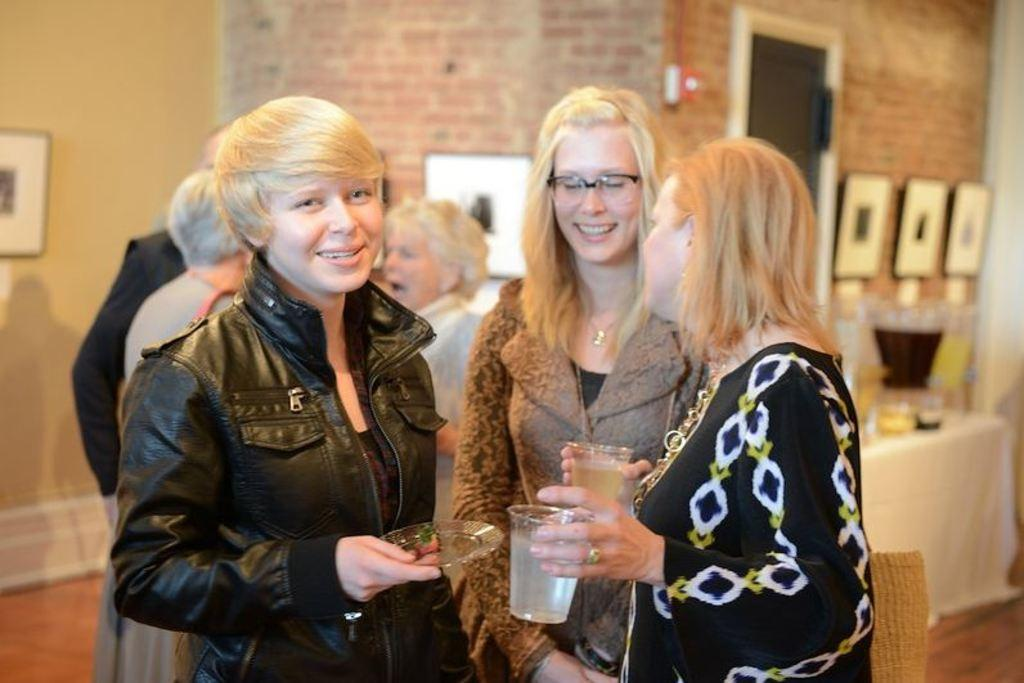What is the main subject of the image? There are two girls standing in the image. Can you describe the appearance of the first girl? The first girl is beautiful and is wearing a black coat. How about the second girl? The second girl is wearing spectacles. What can be seen in the background of the image? There is a brick wall in the background of the image. How many fingers does the fan have in the image? There is no fan present in the image. What type of stretch can be seen in the image? There is no stretch or any object related to stretching in the image. 